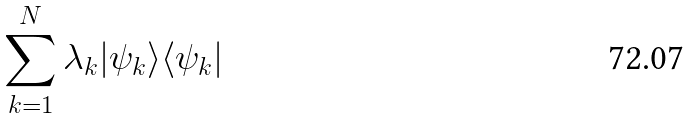Convert formula to latex. <formula><loc_0><loc_0><loc_500><loc_500>\sum _ { k = 1 } ^ { N } \lambda _ { k } | \psi _ { k } \rangle \langle \psi _ { k } |</formula> 